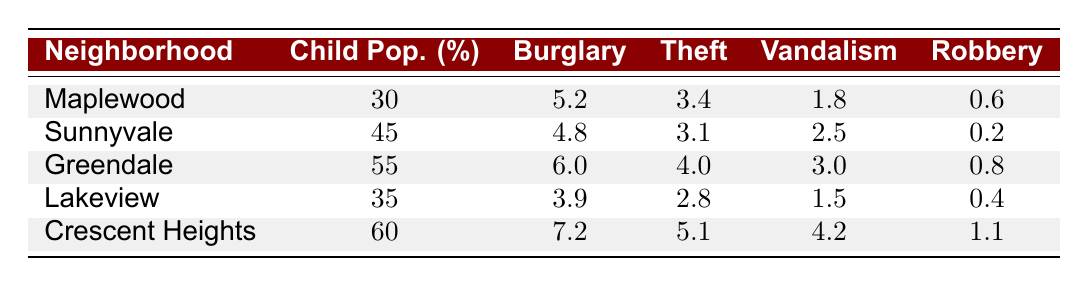What is the burglary rate in Crescent Heights? The table shows that Crescent Heights has a burglary rate of 7.2.
Answer: 7.2 Which neighborhood has the highest theft rate? From the table, Crescent Heights has the highest theft rate at 5.1.
Answer: Crescent Heights Is the robbery rate in Sunnyvale higher than in Lakeview? The table indicates that Sunnyvale has a robbery rate of 0.2, while Lakeview's rate is 0.4, making Lakeview's rate higher.
Answer: No What is the average burglary rate of neighborhoods with a child population percentage of 50 or higher? The neighborhoods with 50 or higher are Greendale (6.0) and Crescent Heights (7.2). Summing these rates gives 6.0 + 7.2 = 13.2. The average is 13.2 / 2 = 6.6.
Answer: 6.6 Does Greendale have a lower vandalism rate than Sunnyvale? The table shows that Greendale has a vandalism rate of 3.0, while Sunnyvale's is 2.5. Therefore, Greendale does not have a lower rate.
Answer: No What is the difference in child population percentage between Crescent Heights and Maplewood? Crescent Heights has a child population percentage of 60, while Maplewood has 30. The difference is 60 - 30 = 30.
Answer: 30 Which neighborhood has the lowest vandalism rate? The table indicates that Lakeview has the lowest vandalism rate at 1.5.
Answer: Lakeview What is the total property crime rate (sum of all rates) for Maplewood? For Maplewood, the rates are: burglary (5.2), theft (3.4), vandalism (1.8), and robbery (0.6). So, the total is 5.2 + 3.4 + 1.8 + 0.6 = 11.0.
Answer: 11.0 